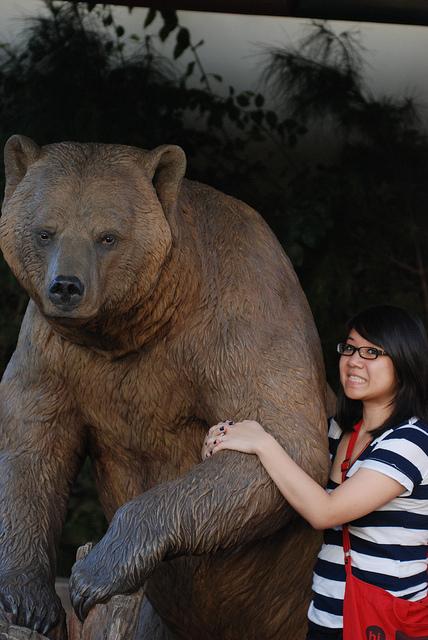What color is the fur?
Be succinct. Brown. What kind of bear is this?
Concise answer only. Grizzly. How many people in this photo?
Concise answer only. 1. What color shirt is the child wearing?
Give a very brief answer. Blue and white. What is looking at the camera?
Short answer required. Girl. What color bear?
Be succinct. Brown. What color is this animal?
Concise answer only. Brown. What type of bear is it?
Be succinct. Brown. How many animals are there in this picture?
Write a very short answer. 1. Would it be safe to approach this animal?
Write a very short answer. No. Does the bear look hungry?
Be succinct. No. What type of animal is this?
Answer briefly. Bear. What country is bear in?
Answer briefly. America. Is the bear attacking the man?
Short answer required. No. Is this a bear?
Quick response, please. Yes. Is the bear happy?
Concise answer only. No. About how tall is the bear?
Quick response, please. 8 feet. Is the women's shirt solid color?
Concise answer only. No. Is he inside?
Short answer required. No. What are the mother and child looking towards?
Short answer required. Camera. What color is the girls bag?
Short answer required. Red. What color is the bear?
Concise answer only. Brown. Is this a black bear?
Be succinct. No. Is the bear sniffing the air?
Write a very short answer. No. Does the bear paw look dangerous?
Give a very brief answer. No. Is she wearing a watch?
Give a very brief answer. No. 